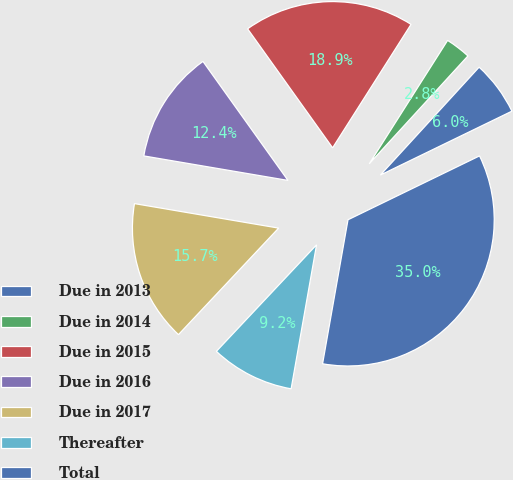Convert chart to OTSL. <chart><loc_0><loc_0><loc_500><loc_500><pie_chart><fcel>Due in 2013<fcel>Due in 2014<fcel>Due in 2015<fcel>Due in 2016<fcel>Due in 2017<fcel>Thereafter<fcel>Total<nl><fcel>6.01%<fcel>2.79%<fcel>18.88%<fcel>12.45%<fcel>15.67%<fcel>9.23%<fcel>34.98%<nl></chart> 